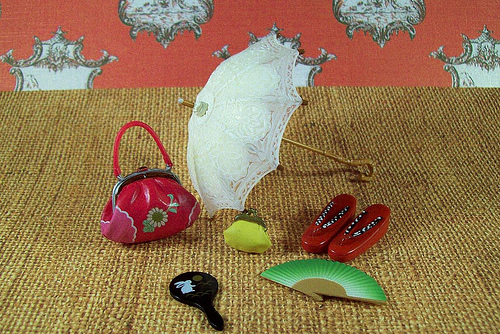<image>
Is the hand fan next to the slipper? Yes. The hand fan is positioned adjacent to the slipper, located nearby in the same general area. 